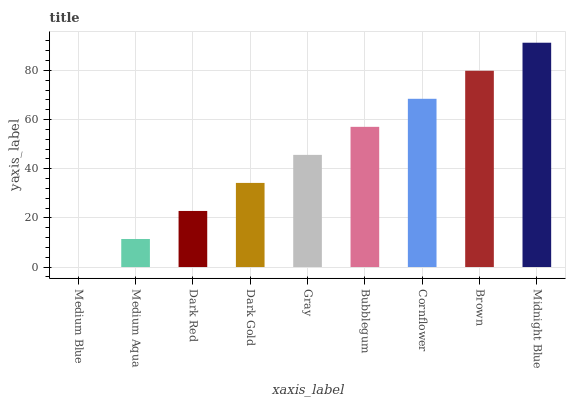Is Medium Blue the minimum?
Answer yes or no. Yes. Is Midnight Blue the maximum?
Answer yes or no. Yes. Is Medium Aqua the minimum?
Answer yes or no. No. Is Medium Aqua the maximum?
Answer yes or no. No. Is Medium Aqua greater than Medium Blue?
Answer yes or no. Yes. Is Medium Blue less than Medium Aqua?
Answer yes or no. Yes. Is Medium Blue greater than Medium Aqua?
Answer yes or no. No. Is Medium Aqua less than Medium Blue?
Answer yes or no. No. Is Gray the high median?
Answer yes or no. Yes. Is Gray the low median?
Answer yes or no. Yes. Is Bubblegum the high median?
Answer yes or no. No. Is Dark Red the low median?
Answer yes or no. No. 